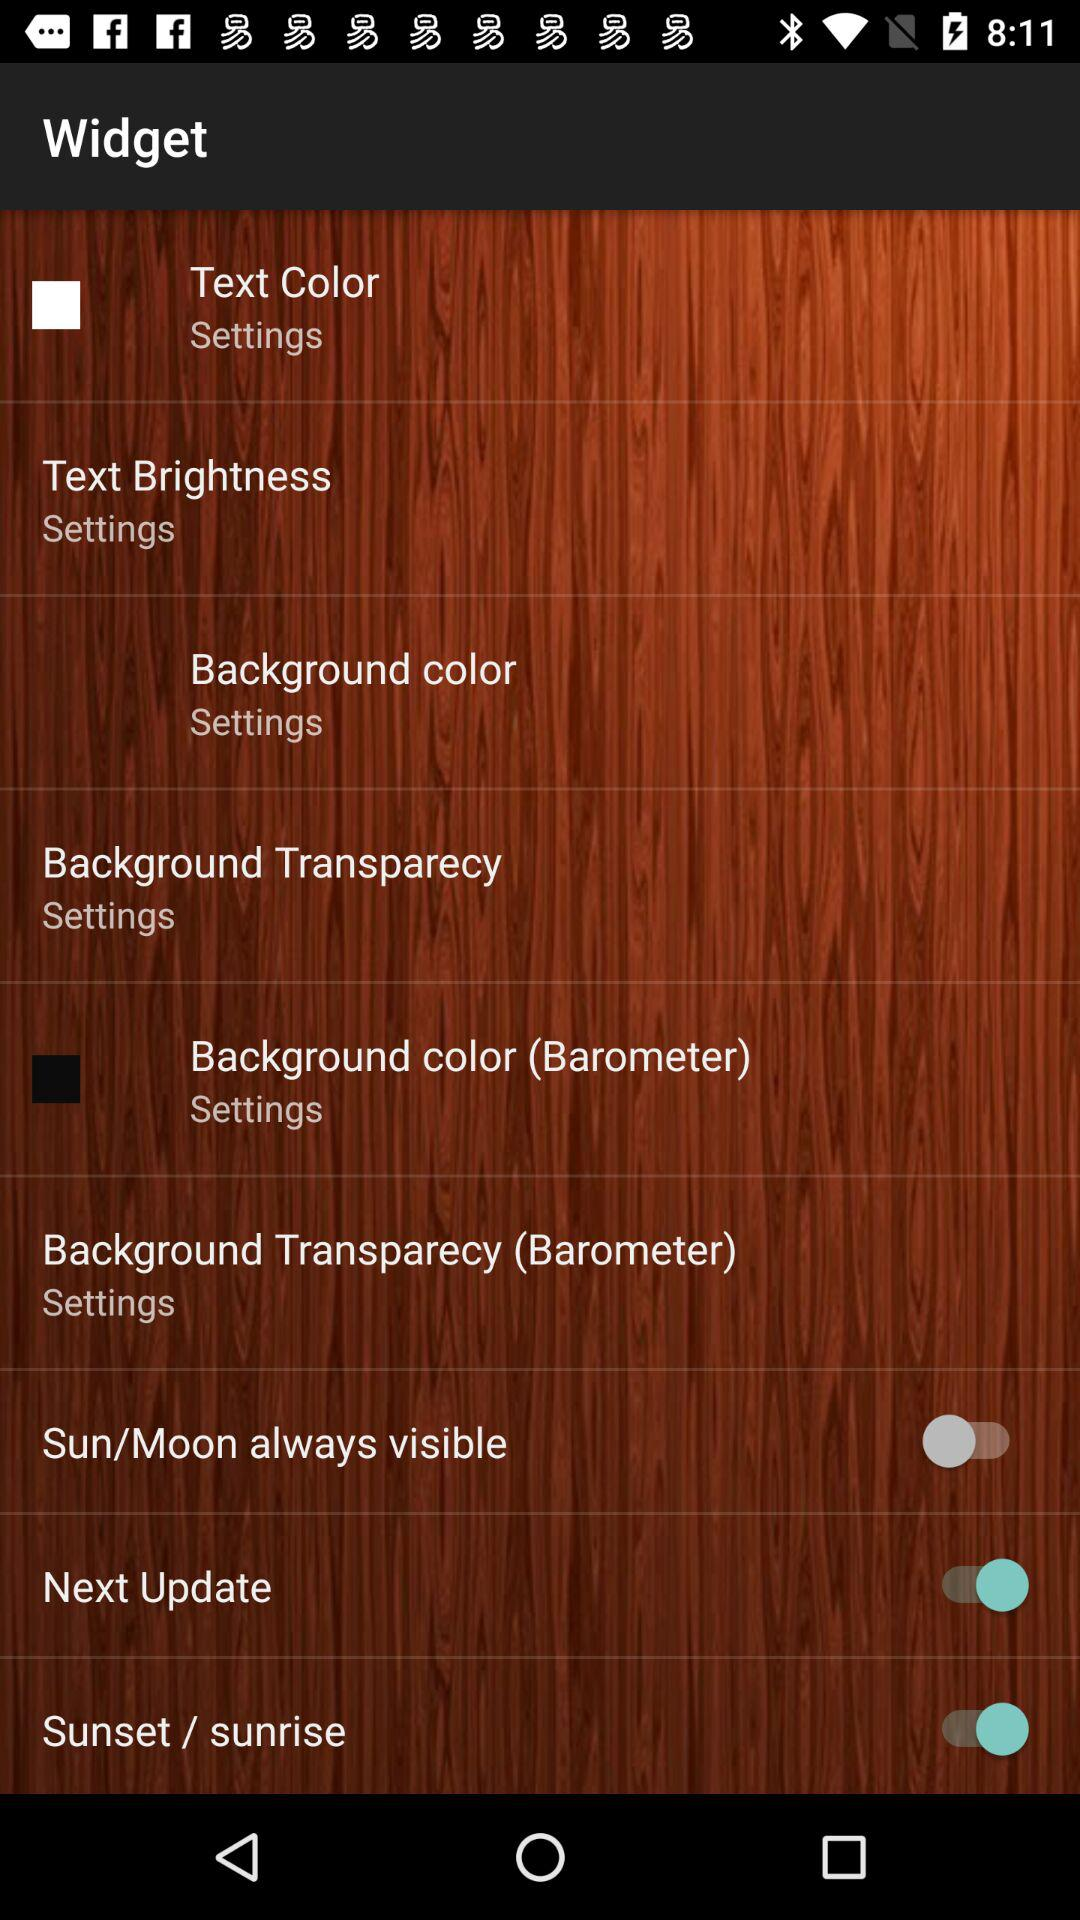How many more background color settings are there for the widget than the barometer?
Answer the question using a single word or phrase. 1 